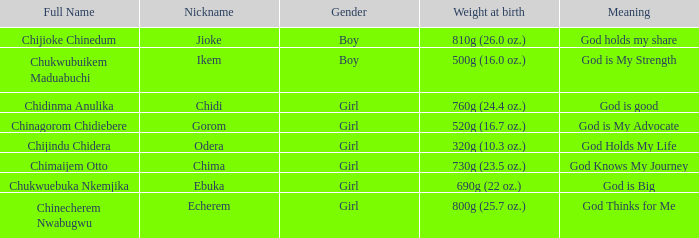What nickname has the meaning of God knows my journey? Chima. 